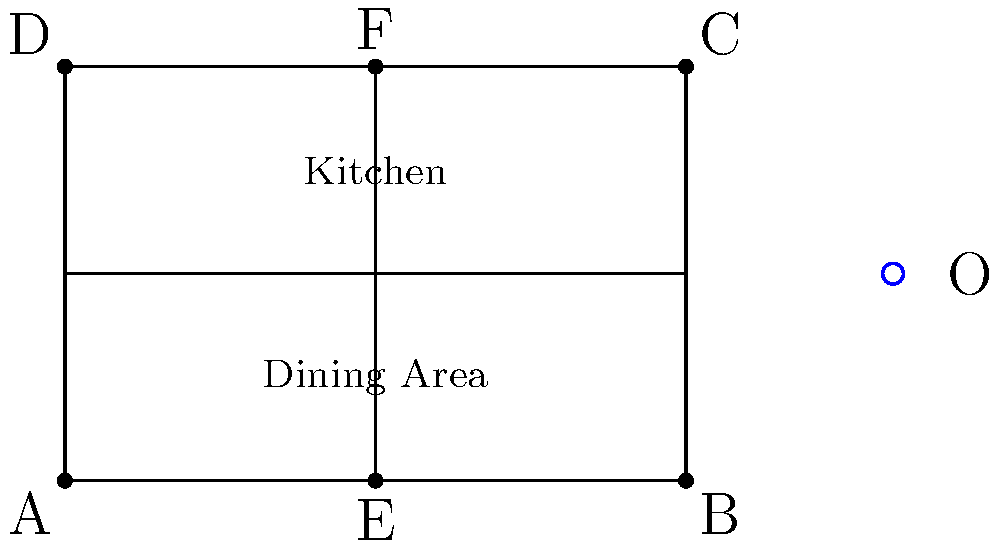As a restaurant owner looking to optimize your seating arrangements, you decide to reflect your current floor plan across a point O to explore alternative layouts. The original floor plan ABCD is reflected to create A'B'C'D'. If the coordinates of point A are (0,0) and point O is (8,2), what are the coordinates of point A' after the reflection? To find the coordinates of A' after reflection across point O, we can follow these steps:

1) The general formula for reflecting a point $(x,y)$ across a point $(a,b)$ is:
   $$(x',y') = (2a-x, 2b-y)$$

2) In this case:
   - Point A has coordinates $(0,0)$
   - Point O has coordinates $(8,2)$

3) Let's substitute these into our formula:
   $x' = 2(8) - 0 = 16$
   $y' = 2(2) - 0 = 4$

4) Therefore, the coordinates of A' are $(16,4)$

This reflection effectively moves the restaurant layout to the other side of point O, potentially revealing new arrangement possibilities that could improve customer flow or maximize seating capacity.
Answer: $(16,4)$ 